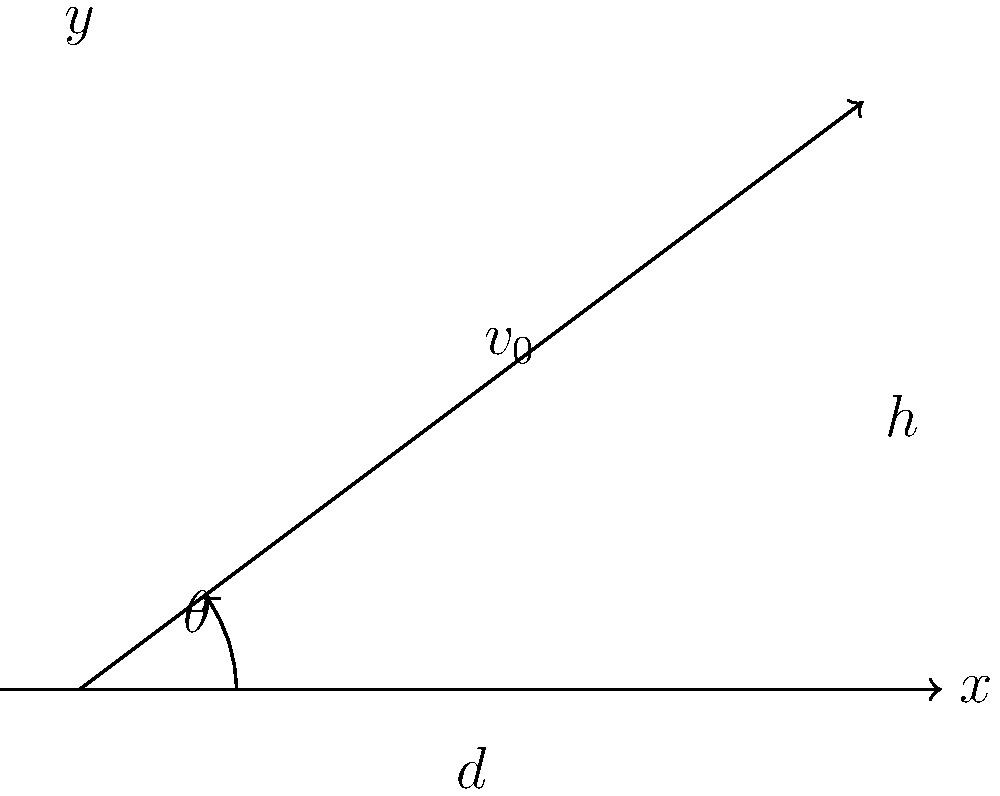A quarterback throws a football with an initial velocity $v_0$ at an angle $\theta$ above the horizontal. The ball reaches a maximum height $h$ and travels a horizontal distance $d$ before landing. Given that $\theta = 36.87°$, $v_0 = 25$ m/s, and $g = 9.8$ m/s², calculate the maximum height $h$ reached by the football. To solve this problem, we'll use the equations of projectile motion:

1) The time to reach the maximum height is given by:
   $$t_{max} = \frac{v_0 \sin(\theta)}{g}$$

2) The maximum height is then calculated using:
   $$h = v_0 \sin(\theta) t_{max} - \frac{1}{2}gt_{max}^2$$

3) Substituting the expression for $t_{max}$ into the height equation:
   $$h = v_0 \sin(\theta) \frac{v_0 \sin(\theta)}{g} - \frac{1}{2}g(\frac{v_0 \sin(\theta)}{g})^2$$

4) Simplifying:
   $$h = \frac{v_0^2 \sin^2(\theta)}{g} - \frac{v_0^2 \sin^2(\theta)}{2g} = \frac{v_0^2 \sin^2(\theta)}{2g}$$

5) Now, let's plug in our values:
   $v_0 = 25$ m/s
   $\theta = 36.87°$
   $g = 9.8$ m/s²

6) Calculate:
   $$h = \frac{(25)^2 \sin^2(36.87°)}{2(9.8)} = \frac{625 * 0.3600}{19.6} = 11.48$$

Therefore, the maximum height reached by the football is approximately 11.48 meters.
Answer: 11.48 m 